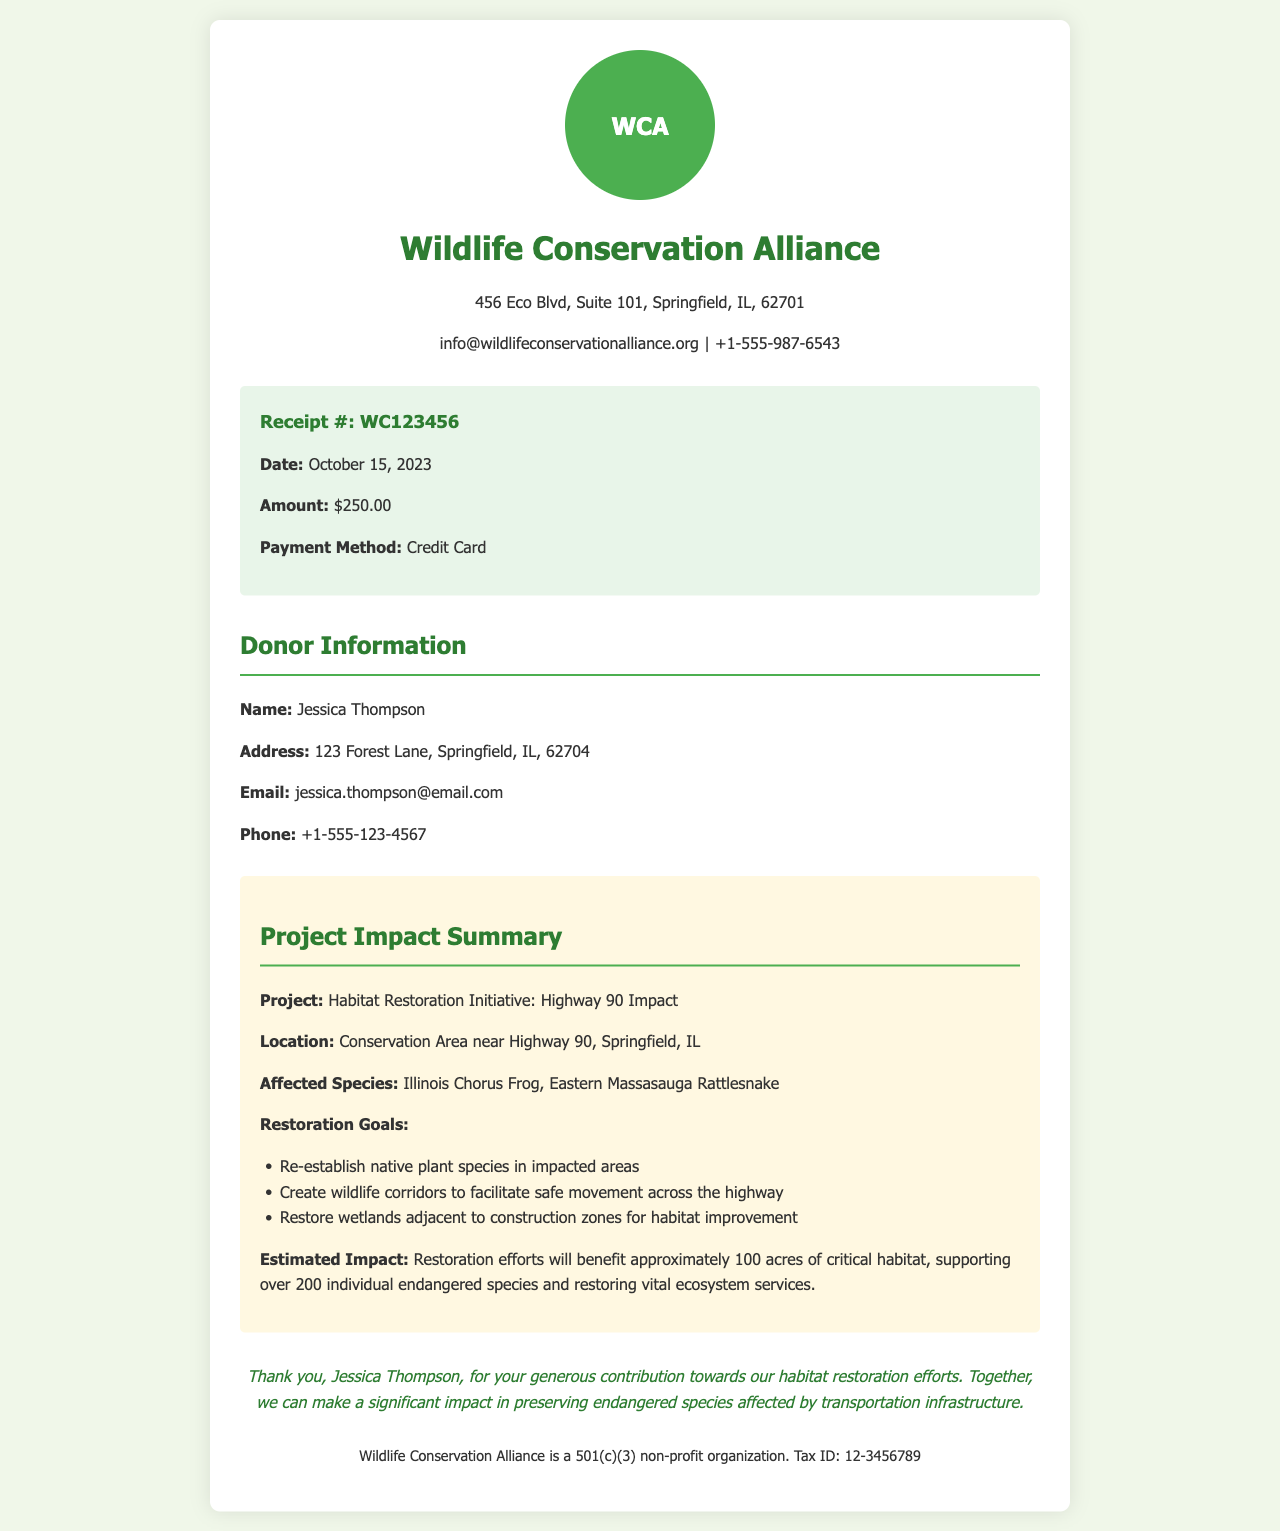What is the receipt number? The receipt number is located in the receipt details section of the document, identified as "Receipt #:".
Answer: WC123456 What is the donation amount? The donation amount is specified in the receipt details as the monetary contribution made by the donor.
Answer: $250.00 Who is the donor? The donor's name is found in the donor information section, under "Name:".
Answer: Jessica Thompson What is the project name? The project name is identified in the project impact summary section as the title of the initiative for which the donation was made.
Answer: Habitat Restoration Initiative: Highway 90 Impact Which species are affected by the highway construction? The affected species are listed in the project impact summary section, highlighting the endangered species impacted by the construction.
Answer: Illinois Chorus Frog, Eastern Massasauga Rattlesnake What is one of the restoration goals? One restoration goal can be found listed in the restoration goals within the project impact summary.
Answer: Re-establish native plant species in impacted areas How many acres will the restoration efforts benefit? The estimated impact section mentions the total area of critical habitat that will be positively impacted by the restoration efforts.
Answer: 100 acres What is the organization's tax ID? The tax ID is mentioned at the bottom of the document, indicating the non-profit organization's identification number.
Answer: 12-3456789 